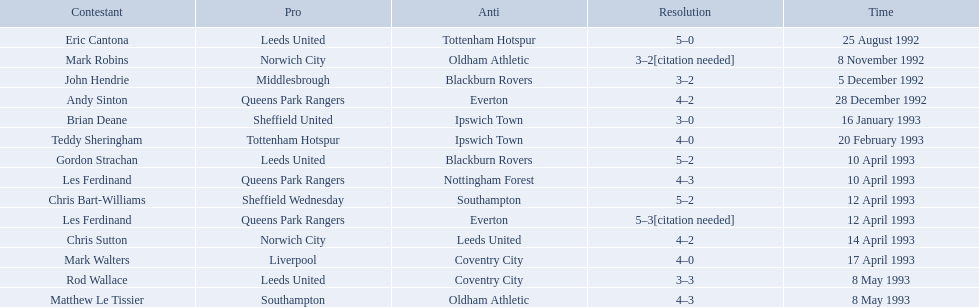Parse the full table in json format. {'header': ['Contestant', 'Pro', 'Anti', 'Resolution', 'Time'], 'rows': [['Eric Cantona', 'Leeds United', 'Tottenham Hotspur', '5–0', '25 August 1992'], ['Mark Robins', 'Norwich City', 'Oldham Athletic', '3–2[citation needed]', '8 November 1992'], ['John Hendrie', 'Middlesbrough', 'Blackburn Rovers', '3–2', '5 December 1992'], ['Andy Sinton', 'Queens Park Rangers', 'Everton', '4–2', '28 December 1992'], ['Brian Deane', 'Sheffield United', 'Ipswich Town', '3–0', '16 January 1993'], ['Teddy Sheringham', 'Tottenham Hotspur', 'Ipswich Town', '4–0', '20 February 1993'], ['Gordon Strachan', 'Leeds United', 'Blackburn Rovers', '5–2', '10 April 1993'], ['Les Ferdinand', 'Queens Park Rangers', 'Nottingham Forest', '4–3', '10 April 1993'], ['Chris Bart-Williams', 'Sheffield Wednesday', 'Southampton', '5–2', '12 April 1993'], ['Les Ferdinand', 'Queens Park Rangers', 'Everton', '5–3[citation needed]', '12 April 1993'], ['Chris Sutton', 'Norwich City', 'Leeds United', '4–2', '14 April 1993'], ['Mark Walters', 'Liverpool', 'Coventry City', '4–0', '17 April 1993'], ['Rod Wallace', 'Leeds United', 'Coventry City', '3–3', '8 May 1993'], ['Matthew Le Tissier', 'Southampton', 'Oldham Athletic', '4–3', '8 May 1993']]} Who are the players in 1992-93 fa premier league? Eric Cantona, Mark Robins, John Hendrie, Andy Sinton, Brian Deane, Teddy Sheringham, Gordon Strachan, Les Ferdinand, Chris Bart-Williams, Les Ferdinand, Chris Sutton, Mark Walters, Rod Wallace, Matthew Le Tissier. What is mark robins' result? 3–2[citation needed]. Which player has the same result? John Hendrie. 